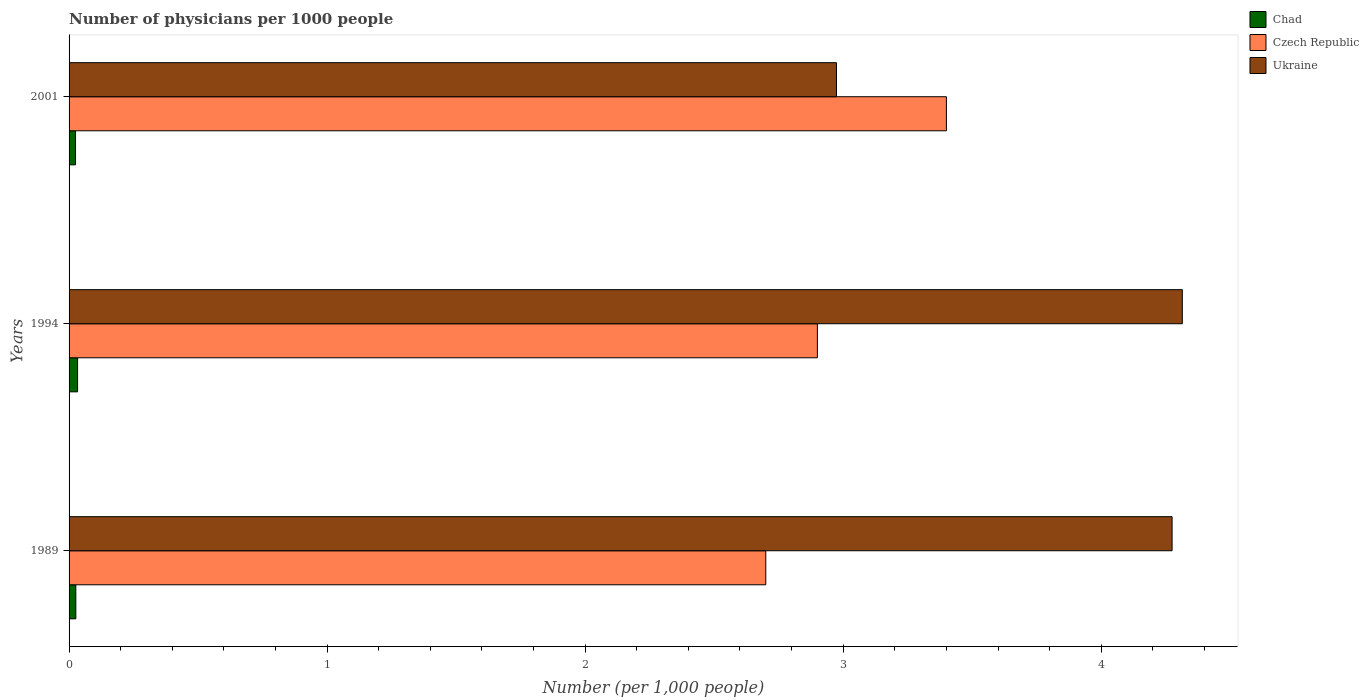How many different coloured bars are there?
Your answer should be compact. 3. Are the number of bars on each tick of the Y-axis equal?
Provide a short and direct response. Yes. How many bars are there on the 3rd tick from the bottom?
Give a very brief answer. 3. In how many cases, is the number of bars for a given year not equal to the number of legend labels?
Your response must be concise. 0. What is the number of physicians in Ukraine in 1989?
Keep it short and to the point. 4.27. In which year was the number of physicians in Chad minimum?
Offer a terse response. 2001. What is the total number of physicians in Chad in the graph?
Give a very brief answer. 0.08. What is the difference between the number of physicians in Ukraine in 1994 and that in 2001?
Offer a very short reply. 1.34. What is the difference between the number of physicians in Czech Republic in 1989 and the number of physicians in Chad in 2001?
Offer a very short reply. 2.68. What is the average number of physicians in Ukraine per year?
Ensure brevity in your answer.  3.85. In the year 2001, what is the difference between the number of physicians in Chad and number of physicians in Czech Republic?
Your response must be concise. -3.38. In how many years, is the number of physicians in Czech Republic greater than 4.2 ?
Offer a terse response. 0. What is the ratio of the number of physicians in Ukraine in 1989 to that in 2001?
Your answer should be compact. 1.44. Is the number of physicians in Chad in 1989 less than that in 1994?
Your answer should be compact. Yes. What is the difference between the highest and the lowest number of physicians in Czech Republic?
Make the answer very short. 0.7. In how many years, is the number of physicians in Chad greater than the average number of physicians in Chad taken over all years?
Make the answer very short. 1. What does the 2nd bar from the top in 1989 represents?
Offer a very short reply. Czech Republic. What does the 2nd bar from the bottom in 2001 represents?
Offer a terse response. Czech Republic. Is it the case that in every year, the sum of the number of physicians in Ukraine and number of physicians in Chad is greater than the number of physicians in Czech Republic?
Offer a very short reply. No. Are all the bars in the graph horizontal?
Provide a succinct answer. Yes. How many years are there in the graph?
Ensure brevity in your answer.  3. Does the graph contain grids?
Give a very brief answer. No. Where does the legend appear in the graph?
Keep it short and to the point. Top right. What is the title of the graph?
Offer a terse response. Number of physicians per 1000 people. What is the label or title of the X-axis?
Provide a short and direct response. Number (per 1,0 people). What is the label or title of the Y-axis?
Provide a succinct answer. Years. What is the Number (per 1,000 people) of Chad in 1989?
Provide a succinct answer. 0.03. What is the Number (per 1,000 people) in Czech Republic in 1989?
Ensure brevity in your answer.  2.7. What is the Number (per 1,000 people) of Ukraine in 1989?
Provide a short and direct response. 4.27. What is the Number (per 1,000 people) in Chad in 1994?
Offer a terse response. 0.03. What is the Number (per 1,000 people) in Ukraine in 1994?
Keep it short and to the point. 4.31. What is the Number (per 1,000 people) of Chad in 2001?
Keep it short and to the point. 0.03. What is the Number (per 1,000 people) in Czech Republic in 2001?
Provide a short and direct response. 3.4. What is the Number (per 1,000 people) in Ukraine in 2001?
Your response must be concise. 2.97. Across all years, what is the maximum Number (per 1,000 people) in Chad?
Offer a very short reply. 0.03. Across all years, what is the maximum Number (per 1,000 people) of Czech Republic?
Give a very brief answer. 3.4. Across all years, what is the maximum Number (per 1,000 people) of Ukraine?
Your response must be concise. 4.31. Across all years, what is the minimum Number (per 1,000 people) in Chad?
Give a very brief answer. 0.03. Across all years, what is the minimum Number (per 1,000 people) of Czech Republic?
Ensure brevity in your answer.  2.7. Across all years, what is the minimum Number (per 1,000 people) in Ukraine?
Your answer should be compact. 2.97. What is the total Number (per 1,000 people) in Chad in the graph?
Your answer should be very brief. 0.08. What is the total Number (per 1,000 people) in Ukraine in the graph?
Your answer should be compact. 11.56. What is the difference between the Number (per 1,000 people) in Chad in 1989 and that in 1994?
Make the answer very short. -0.01. What is the difference between the Number (per 1,000 people) in Czech Republic in 1989 and that in 1994?
Offer a terse response. -0.2. What is the difference between the Number (per 1,000 people) of Ukraine in 1989 and that in 1994?
Your answer should be very brief. -0.04. What is the difference between the Number (per 1,000 people) of Chad in 1989 and that in 2001?
Your answer should be compact. 0. What is the difference between the Number (per 1,000 people) of Czech Republic in 1989 and that in 2001?
Your response must be concise. -0.7. What is the difference between the Number (per 1,000 people) in Ukraine in 1989 and that in 2001?
Provide a short and direct response. 1.3. What is the difference between the Number (per 1,000 people) in Chad in 1994 and that in 2001?
Your answer should be compact. 0.01. What is the difference between the Number (per 1,000 people) in Czech Republic in 1994 and that in 2001?
Give a very brief answer. -0.5. What is the difference between the Number (per 1,000 people) in Ukraine in 1994 and that in 2001?
Provide a short and direct response. 1.34. What is the difference between the Number (per 1,000 people) of Chad in 1989 and the Number (per 1,000 people) of Czech Republic in 1994?
Give a very brief answer. -2.87. What is the difference between the Number (per 1,000 people) in Chad in 1989 and the Number (per 1,000 people) in Ukraine in 1994?
Give a very brief answer. -4.29. What is the difference between the Number (per 1,000 people) in Czech Republic in 1989 and the Number (per 1,000 people) in Ukraine in 1994?
Give a very brief answer. -1.61. What is the difference between the Number (per 1,000 people) of Chad in 1989 and the Number (per 1,000 people) of Czech Republic in 2001?
Ensure brevity in your answer.  -3.37. What is the difference between the Number (per 1,000 people) of Chad in 1989 and the Number (per 1,000 people) of Ukraine in 2001?
Offer a terse response. -2.95. What is the difference between the Number (per 1,000 people) in Czech Republic in 1989 and the Number (per 1,000 people) in Ukraine in 2001?
Offer a very short reply. -0.27. What is the difference between the Number (per 1,000 people) of Chad in 1994 and the Number (per 1,000 people) of Czech Republic in 2001?
Provide a short and direct response. -3.37. What is the difference between the Number (per 1,000 people) of Chad in 1994 and the Number (per 1,000 people) of Ukraine in 2001?
Make the answer very short. -2.94. What is the difference between the Number (per 1,000 people) of Czech Republic in 1994 and the Number (per 1,000 people) of Ukraine in 2001?
Ensure brevity in your answer.  -0.07. What is the average Number (per 1,000 people) in Chad per year?
Your answer should be compact. 0.03. What is the average Number (per 1,000 people) in Czech Republic per year?
Your answer should be compact. 3. What is the average Number (per 1,000 people) of Ukraine per year?
Your answer should be very brief. 3.85. In the year 1989, what is the difference between the Number (per 1,000 people) in Chad and Number (per 1,000 people) in Czech Republic?
Keep it short and to the point. -2.67. In the year 1989, what is the difference between the Number (per 1,000 people) in Chad and Number (per 1,000 people) in Ukraine?
Provide a succinct answer. -4.25. In the year 1989, what is the difference between the Number (per 1,000 people) of Czech Republic and Number (per 1,000 people) of Ukraine?
Give a very brief answer. -1.57. In the year 1994, what is the difference between the Number (per 1,000 people) in Chad and Number (per 1,000 people) in Czech Republic?
Make the answer very short. -2.87. In the year 1994, what is the difference between the Number (per 1,000 people) in Chad and Number (per 1,000 people) in Ukraine?
Provide a short and direct response. -4.28. In the year 1994, what is the difference between the Number (per 1,000 people) of Czech Republic and Number (per 1,000 people) of Ukraine?
Make the answer very short. -1.41. In the year 2001, what is the difference between the Number (per 1,000 people) in Chad and Number (per 1,000 people) in Czech Republic?
Your answer should be compact. -3.38. In the year 2001, what is the difference between the Number (per 1,000 people) of Chad and Number (per 1,000 people) of Ukraine?
Offer a very short reply. -2.95. In the year 2001, what is the difference between the Number (per 1,000 people) in Czech Republic and Number (per 1,000 people) in Ukraine?
Your answer should be very brief. 0.43. What is the ratio of the Number (per 1,000 people) of Chad in 1989 to that in 1994?
Your answer should be compact. 0.79. What is the ratio of the Number (per 1,000 people) in Ukraine in 1989 to that in 1994?
Make the answer very short. 0.99. What is the ratio of the Number (per 1,000 people) in Chad in 1989 to that in 2001?
Provide a short and direct response. 1.05. What is the ratio of the Number (per 1,000 people) in Czech Republic in 1989 to that in 2001?
Make the answer very short. 0.79. What is the ratio of the Number (per 1,000 people) of Ukraine in 1989 to that in 2001?
Your answer should be compact. 1.44. What is the ratio of the Number (per 1,000 people) of Chad in 1994 to that in 2001?
Make the answer very short. 1.32. What is the ratio of the Number (per 1,000 people) of Czech Republic in 1994 to that in 2001?
Provide a short and direct response. 0.85. What is the ratio of the Number (per 1,000 people) of Ukraine in 1994 to that in 2001?
Provide a succinct answer. 1.45. What is the difference between the highest and the second highest Number (per 1,000 people) in Chad?
Ensure brevity in your answer.  0.01. What is the difference between the highest and the second highest Number (per 1,000 people) in Czech Republic?
Offer a very short reply. 0.5. What is the difference between the highest and the second highest Number (per 1,000 people) in Ukraine?
Your answer should be compact. 0.04. What is the difference between the highest and the lowest Number (per 1,000 people) in Chad?
Keep it short and to the point. 0.01. What is the difference between the highest and the lowest Number (per 1,000 people) of Czech Republic?
Offer a very short reply. 0.7. What is the difference between the highest and the lowest Number (per 1,000 people) in Ukraine?
Your response must be concise. 1.34. 